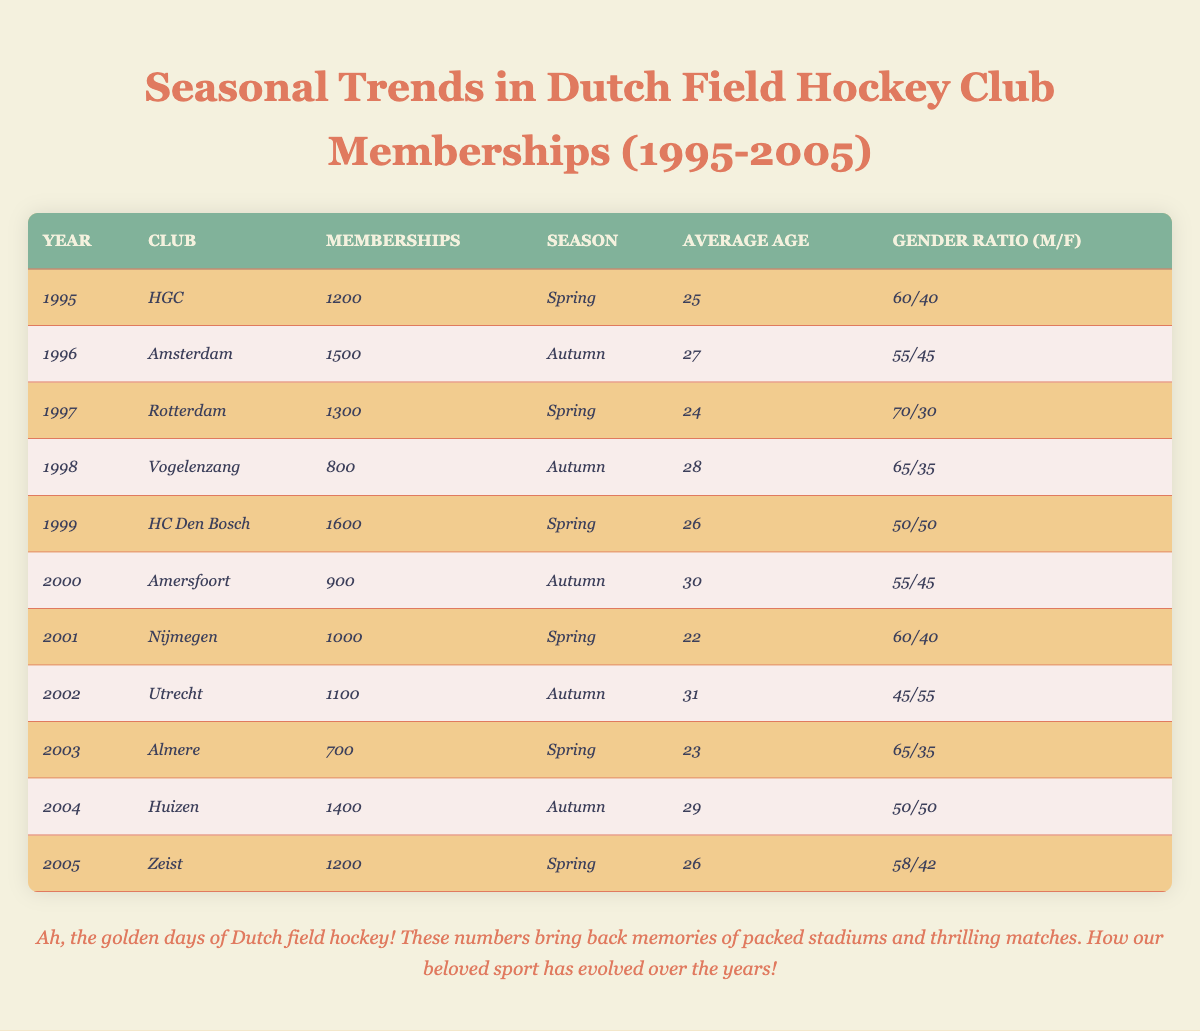What was the highest number of memberships in a single year from 1995 to 2005? In the provided table, the highest number of memberships is found in 1999 with HC Den Bosch at 1600 memberships.
Answer: 1600 Which club had the fewest memberships in autumn during this period? Looking through the autumn seasons in the table, Vogelenzang in 1998 had the lowest memberships at 800.
Answer: Vogelenzang What was the average age of members for the club 'Nijmegen' in 2001? Referring to the 2001 row for Nijmegen, the average age is given as 22.
Answer: 22 Calculate the total memberships in 1995 and 1996. The total memberships for the years 1995 (1200) and 1996 (1500) can be calculated as 1200 + 1500 = 2700.
Answer: 2700 Did the gender ratio of HC Den Bosch in 1999 reflect equal participation between males and females? The gender ratio for HC Den Bosch in 1999 is 50/50, indicating equal participation between males and females.
Answer: Yes What seasons did the clubs 'HGC' and 'HC Den Bosch' have their memberships recorded? HGC was recorded in Spring 1995, while HC Den Bosch was recorded in Spring 1999.
Answer: Spring Was the average age of members generally increasing over this period? Examining the average ages from each year, there is variation, but it averages around mid-20s with some years showing older members, which suggests the trend varies instead of a definite increase.
Answer: No What is the gender ratio of memberships for the club 'Utrecht' in 2002, and how does it compare to other years? The gender ratio for Utrecht in 2002 is 45/55, which is skewed towards female members. Compared with other years, most clubs have a more balanced or male-skewed ratio.
Answer: 45/55 (more female) Which season had the most members overall from all clubs in the table? By adding memberships across all seasons, Spring totals (1200 + 1300 + 1600 + 1000 + 700 + 1200 = 5300) and Autumn totals (1500 + 800 + 900 + 1100 + 1400 = 4900) show Spring had more.
Answer: Spring In which year did the club have the highest average age, and what was it? The highest average age recorded in the table is 31 for Utrecht in 2002.
Answer: 31 